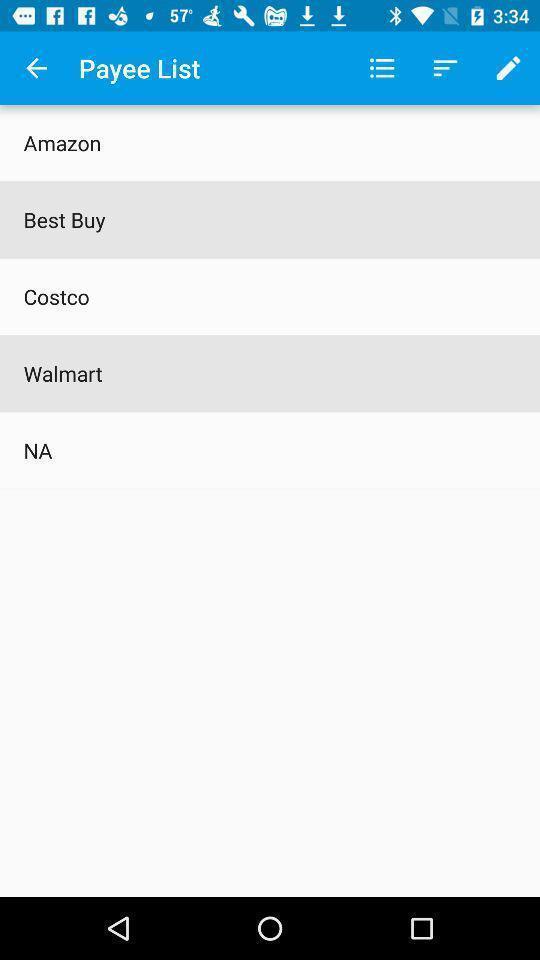Provide a textual representation of this image. Page showing payee list of a financial app. 